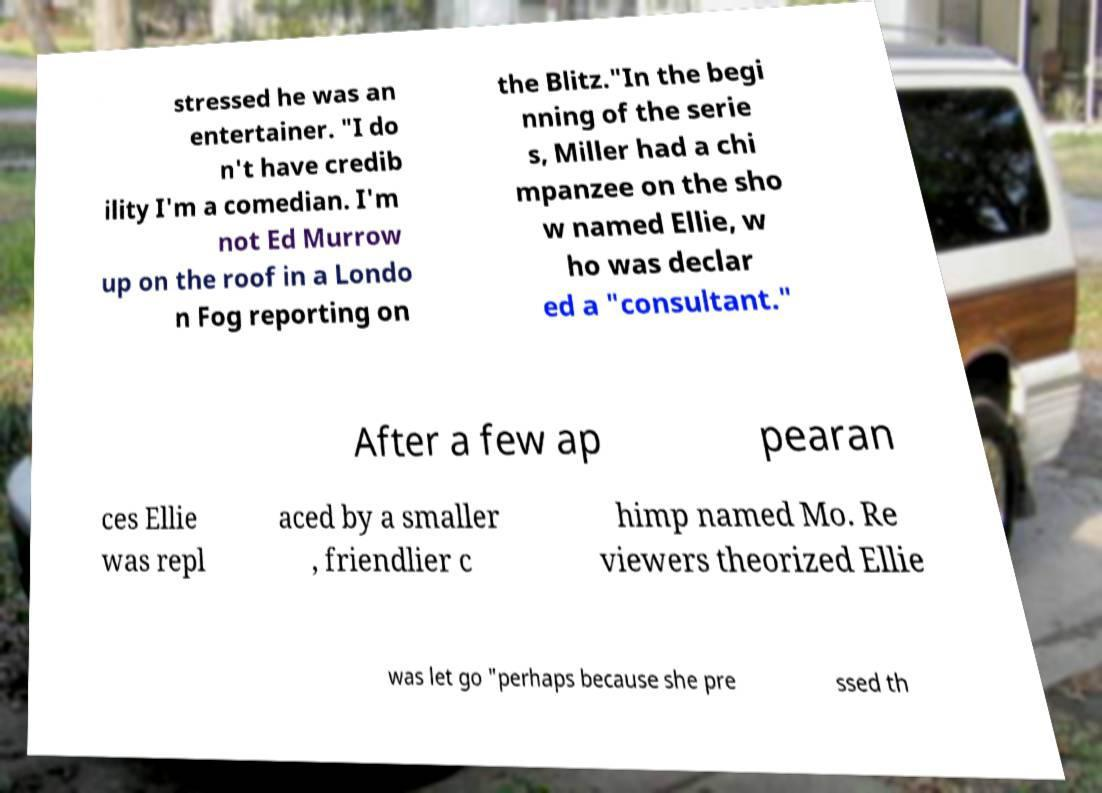I need the written content from this picture converted into text. Can you do that? stressed he was an entertainer. "I do n't have credib ility I'm a comedian. I'm not Ed Murrow up on the roof in a Londo n Fog reporting on the Blitz."In the begi nning of the serie s, Miller had a chi mpanzee on the sho w named Ellie, w ho was declar ed a "consultant." After a few ap pearan ces Ellie was repl aced by a smaller , friendlier c himp named Mo. Re viewers theorized Ellie was let go "perhaps because she pre ssed th 